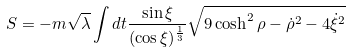<formula> <loc_0><loc_0><loc_500><loc_500>S = - m \sqrt { \lambda } \int d t \frac { \sin \xi } { ( \cos \xi ) ^ { \frac { 1 } { 3 } } } \sqrt { 9 \cosh ^ { 2 } \rho - \dot { \rho } ^ { 2 } - 4 \dot { \xi } ^ { 2 } }</formula> 